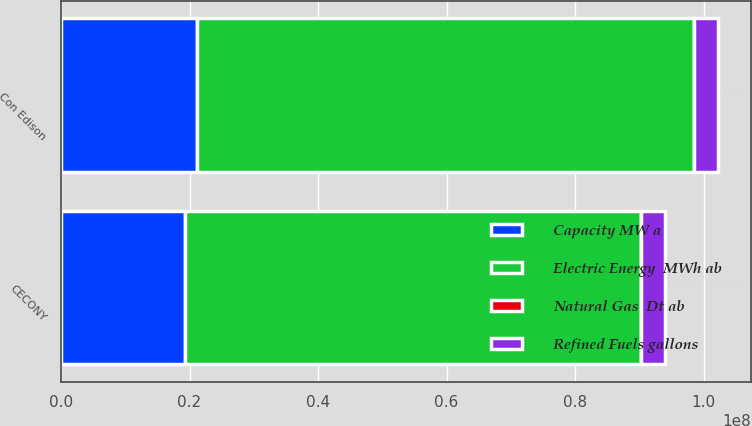<chart> <loc_0><loc_0><loc_500><loc_500><stacked_bar_chart><ecel><fcel>Con Edison<fcel>CECONY<nl><fcel>Capacity MW a<fcel>2.12358e+07<fcel>1.92584e+07<nl><fcel>Natural Gas  Dt ab<fcel>13616<fcel>7500<nl><fcel>Electric Energy  MWh ab<fcel>7.72488e+07<fcel>7.106e+07<nl><fcel>Refined Fuels gallons<fcel>3.696e+06<fcel>3.696e+06<nl></chart> 